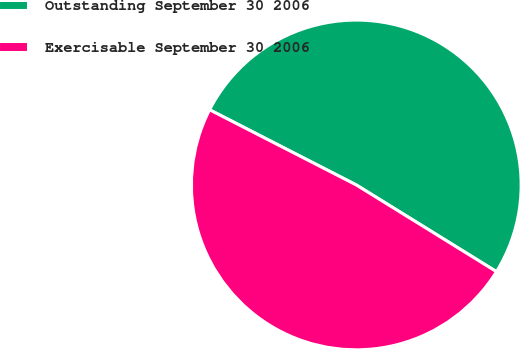Convert chart to OTSL. <chart><loc_0><loc_0><loc_500><loc_500><pie_chart><fcel>Outstanding September 30 2006<fcel>Exercisable September 30 2006<nl><fcel>51.28%<fcel>48.72%<nl></chart> 